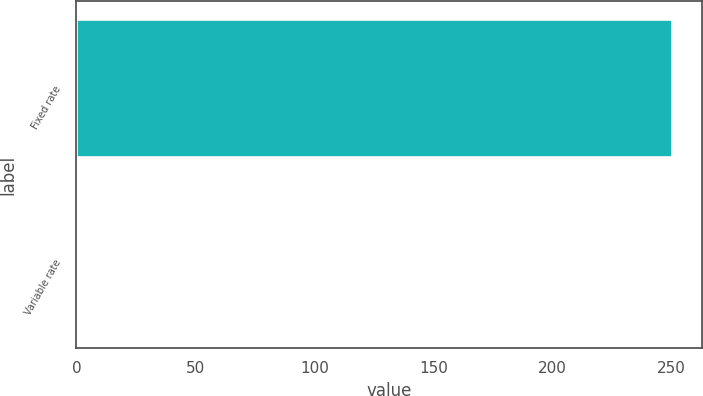<chart> <loc_0><loc_0><loc_500><loc_500><bar_chart><fcel>Fixed rate<fcel>Variable rate<nl><fcel>250.2<fcel>0.5<nl></chart> 